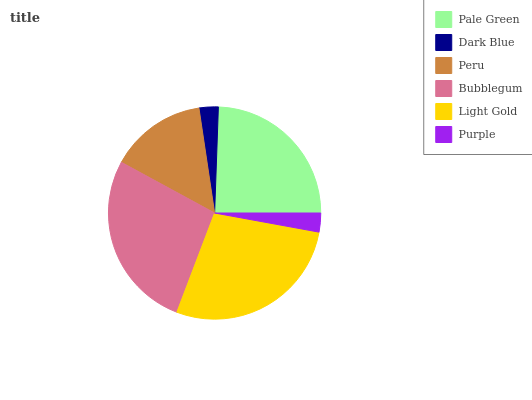Is Purple the minimum?
Answer yes or no. Yes. Is Light Gold the maximum?
Answer yes or no. Yes. Is Dark Blue the minimum?
Answer yes or no. No. Is Dark Blue the maximum?
Answer yes or no. No. Is Pale Green greater than Dark Blue?
Answer yes or no. Yes. Is Dark Blue less than Pale Green?
Answer yes or no. Yes. Is Dark Blue greater than Pale Green?
Answer yes or no. No. Is Pale Green less than Dark Blue?
Answer yes or no. No. Is Pale Green the high median?
Answer yes or no. Yes. Is Peru the low median?
Answer yes or no. Yes. Is Peru the high median?
Answer yes or no. No. Is Purple the low median?
Answer yes or no. No. 